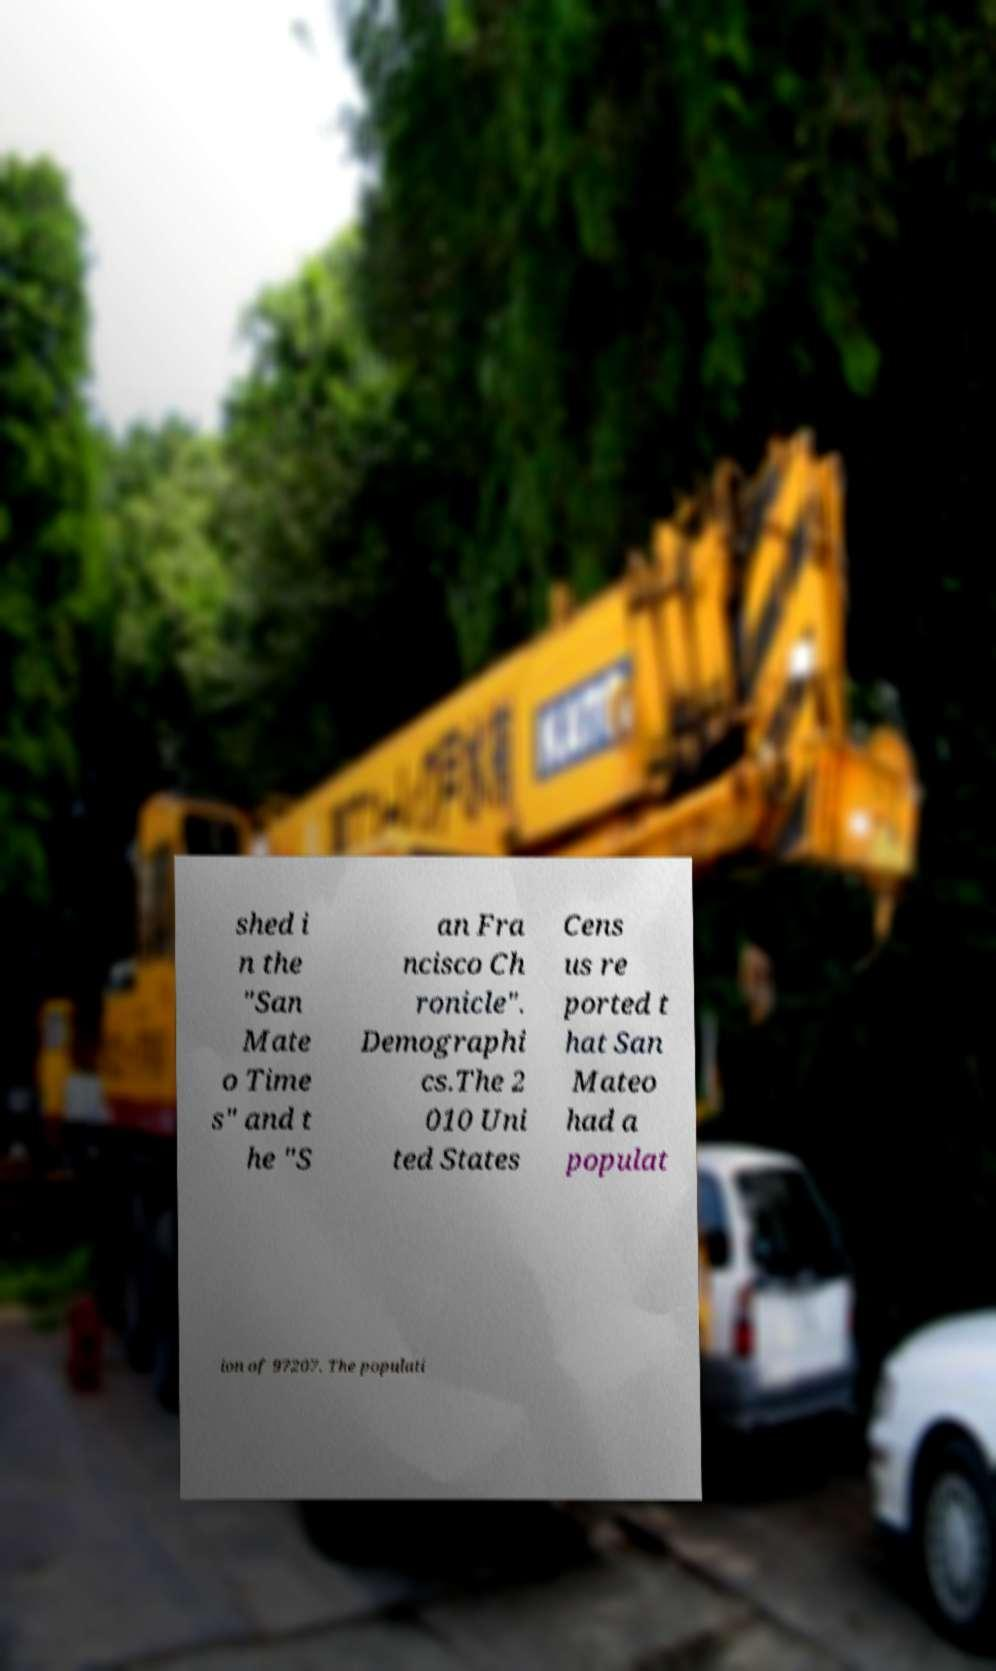There's text embedded in this image that I need extracted. Can you transcribe it verbatim? shed i n the "San Mate o Time s" and t he "S an Fra ncisco Ch ronicle". Demographi cs.The 2 010 Uni ted States Cens us re ported t hat San Mateo had a populat ion of 97207. The populati 